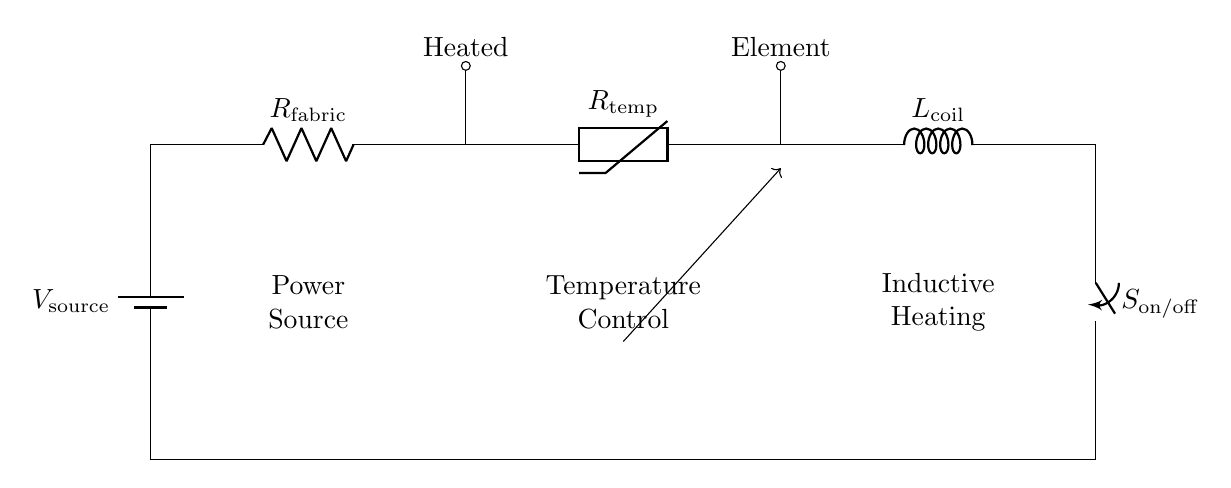What type of components are included in this circuit? The circuit includes a battery, a resistor labeled R_fabric, a thermistor labeled R_temp, an inductor labeled L_coil, and a switch labeled S_on/off. These components are found along the path of the circuit.
Answer: battery, resistor, thermistor, inductor, switch What is the purpose of the thermistor in this circuit? The thermistor, or R_temp, is used for temperature control by varying its resistance based on the temperature, affecting the current flow in the circuit.
Answer: temperature control What is the role of the switch in this circuit? The switch, S_on/off, is used to either allow or interrupt the flow of current in the circuit, hence controlling the entire heating system.
Answer: current control What does the inductor L_coil signify in the context of this circuit? The inductor is used for inductive heating, indicating that it generates heat due to its electrical resistance when current passes through it.
Answer: inductive heating What temperature-related functionality does the circuit provide? The circuit is designed to control temperature by adjusting the resistance of the thermistor, thereby regulating the amount of current to the heating elements based on the desired temperature.
Answer: temperature regulation How does the temperature control affect the heated elements? The temperature control, via the thermistor, modulates resistance which subsequently regulates current flow to the heated elements, impacting their temperature output.
Answer: modulated heating 